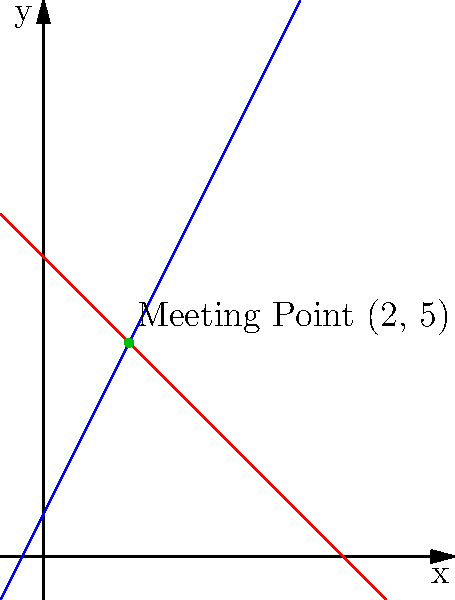Two tribes, the River Tribe and the Mountain Tribe, are planning to meet at a sacred location. The River Tribe's path can be represented by the equation $y = 2x + 1$, while the Mountain Tribe's path is described by $y = -x + 7$. At what point $(x, y)$ will the two tribes meet? To find the intersection point of the two paths, we need to solve the system of equations:

1) River Tribe's path: $y = 2x + 1$
2) Mountain Tribe's path: $y = -x + 7$

At the intersection point, the $y$ values will be equal. So we can set the equations equal to each other:

$$2x + 1 = -x + 7$$

Now, let's solve for $x$:

$$2x + 1 = -x + 7$$
$$3x = 6$$
$$x = 2$$

Now that we know the $x$-coordinate of the intersection point, we can substitute it into either of the original equations to find the $y$-coordinate. Let's use the River Tribe's equation:

$$y = 2x + 1$$
$$y = 2(2) + 1$$
$$y = 4 + 1 = 5$$

Therefore, the two tribes will meet at the point $(2, 5)$.
Answer: (2, 5) 